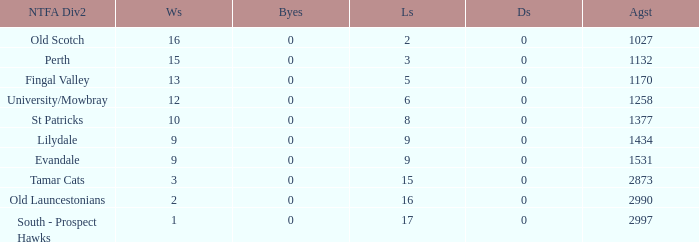What is the lowest number of against of NTFA Div 2 Fingal Valley? 1170.0. 